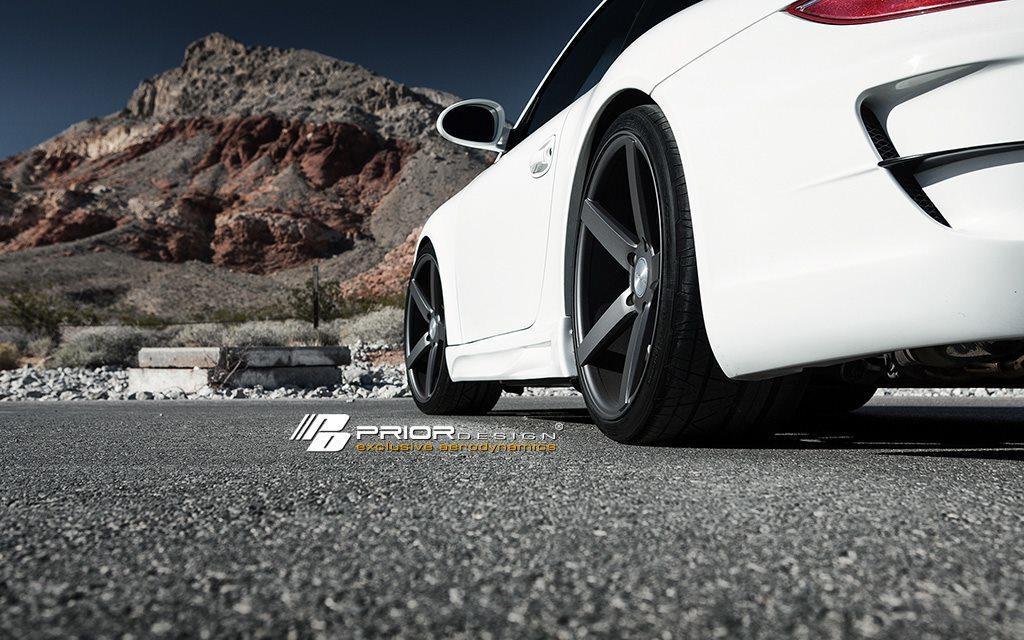Could you give a brief overview of what you see in this image? In the middle of this image, there is a watermark. On the right side, there is a white color vehicle on the road. In the background, there are rocks, trees, plants and there are clouds in the sky. 